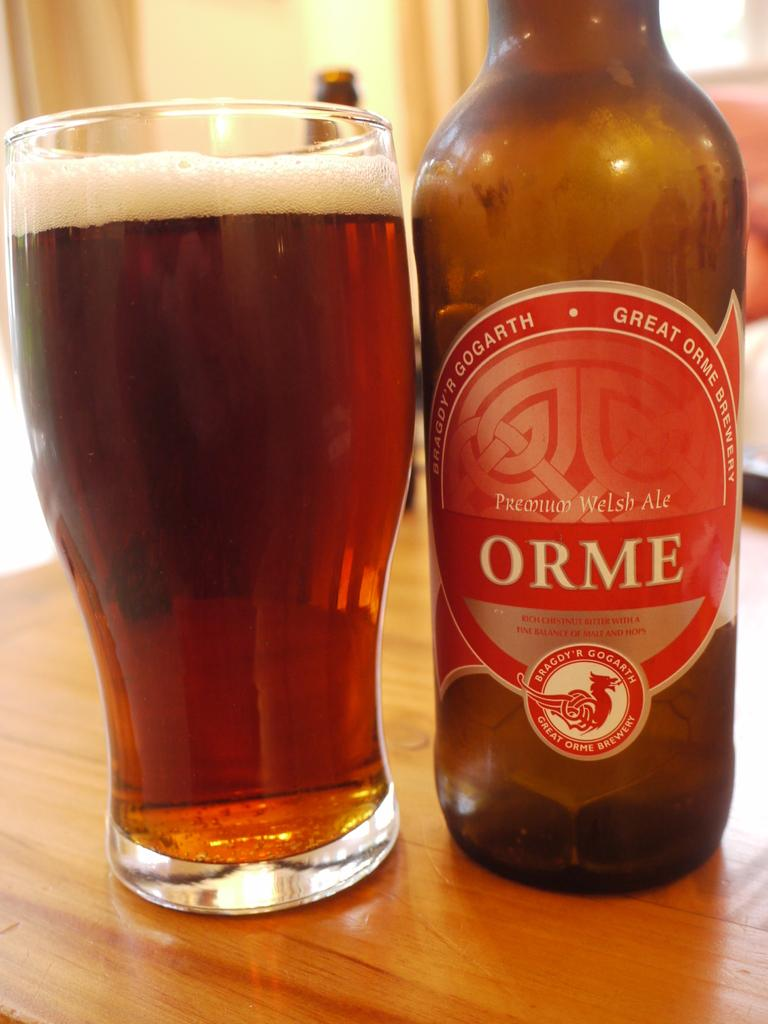<image>
Share a concise interpretation of the image provided. A bottle and glass of ORME beer sits on a table. 